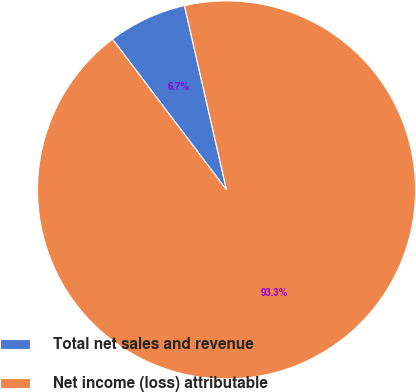Convert chart. <chart><loc_0><loc_0><loc_500><loc_500><pie_chart><fcel>Total net sales and revenue<fcel>Net income (loss) attributable<nl><fcel>6.74%<fcel>93.26%<nl></chart> 